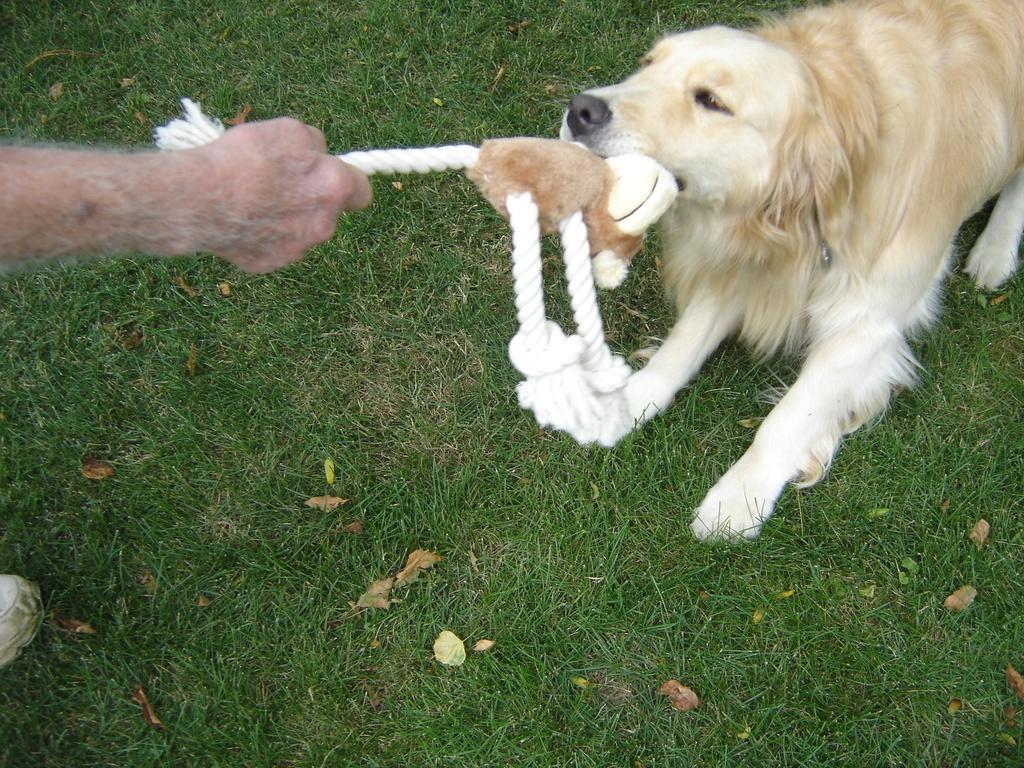Can you describe this image briefly? Land is covered with grass. A person and dog is holding this toy. 